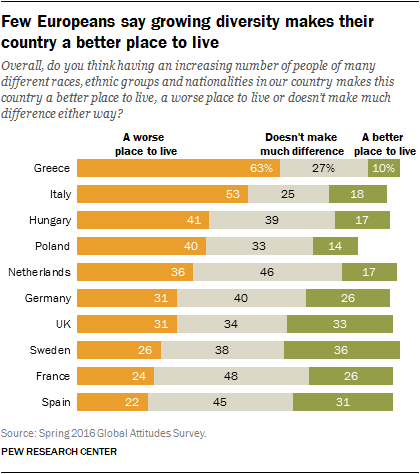Point out several critical features in this image. I am unable to complete this task as it is unclear what the specific context or question being asked is. Please provide more information or clarify your request. A significant percentage of people believe that Greece is a better place to live than 10%. 